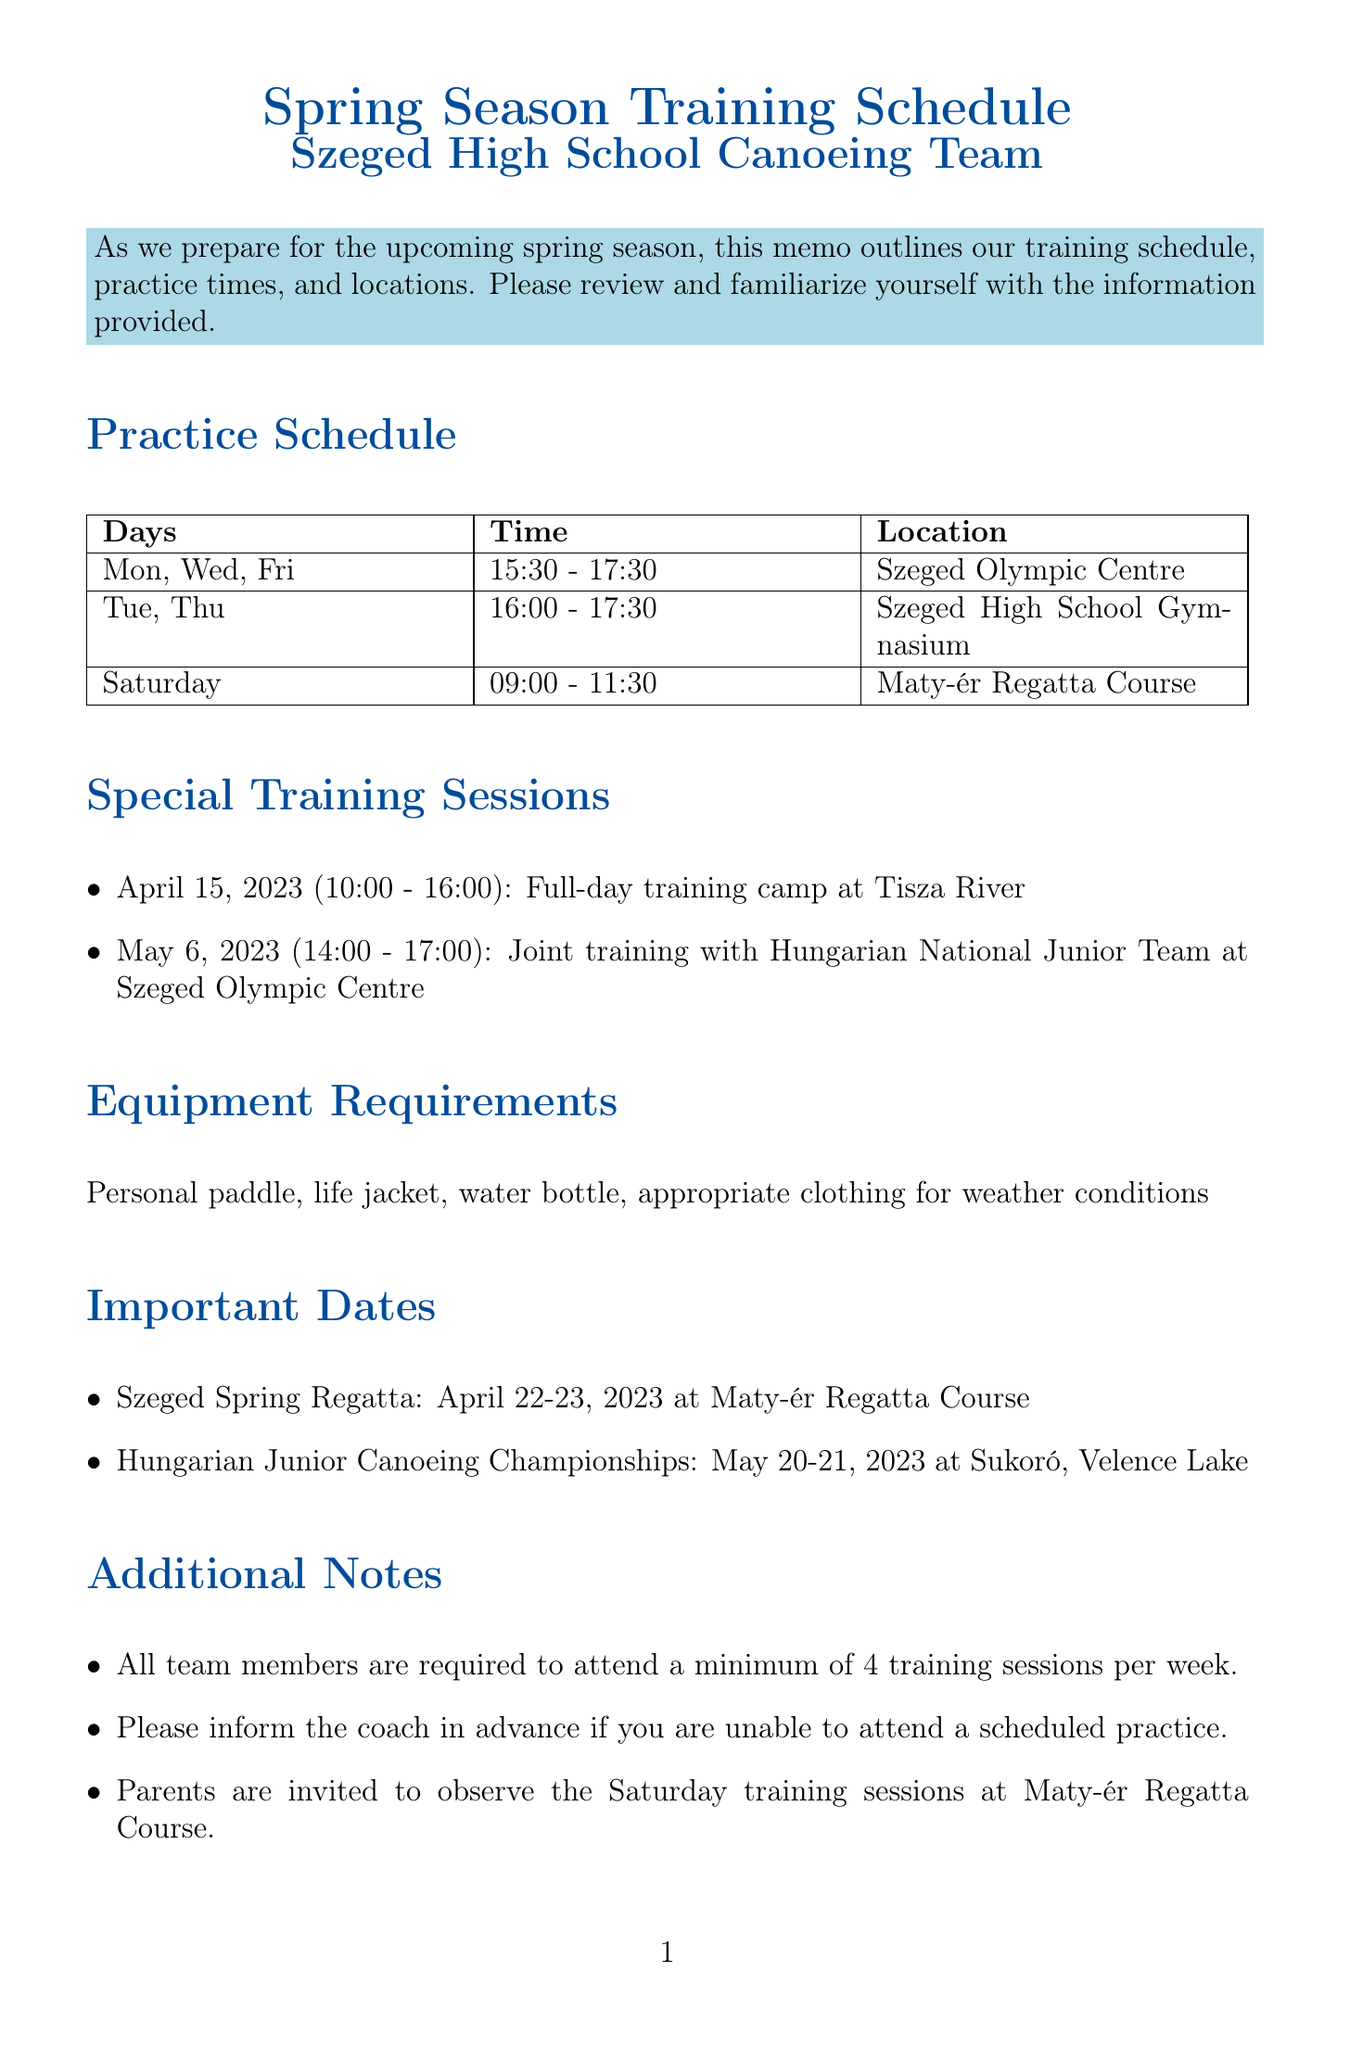What is the title of the memo? The title of the memo is stated at the beginning, indicating the main topic discussed.
Answer: Spring Season Training Schedule for Szeged High School Canoeing Team What days are reserved for strength and conditioning exercises? The document lists the specific days dedicated to strength and conditioning, which is important for training focus.
Answer: Tuesday, Thursday What time does the Saturday practice start? The starting time for Saturday practices is specified in the schedule, indicating when the team will convene.
Answer: 09:00 When is the Szeged Spring Regatta scheduled? The document includes important dates, allowing to identify when significant events are taking place.
Answer: April 22-23, 2023 What is required equipment for training? The memo provides a list of items necessary for practice, ensuring athletes are properly prepared.
Answer: Personal paddle, life jacket, water bottle, appropriate clothing for weather conditions How many training sessions are team members required to attend weekly? The instructions in the memo mention a minimum attendance requirement, guiding team commitment.
Answer: 4 training sessions Where will the joint training session with the Hungarian National Junior Team take place? The location for the special training session is mentioned, giving important logistical information.
Answer: Szeged Olympic Centre What is the focus of the weekday training sessions? The memo outlines the focus areas for training, which is essential for planning practice effectively.
Answer: On-water technique and endurance training Who is the coach of the canoeing team? The contact information section identifies the leader of the team, crucial for any communications.
Answer: Gábor Nagy 